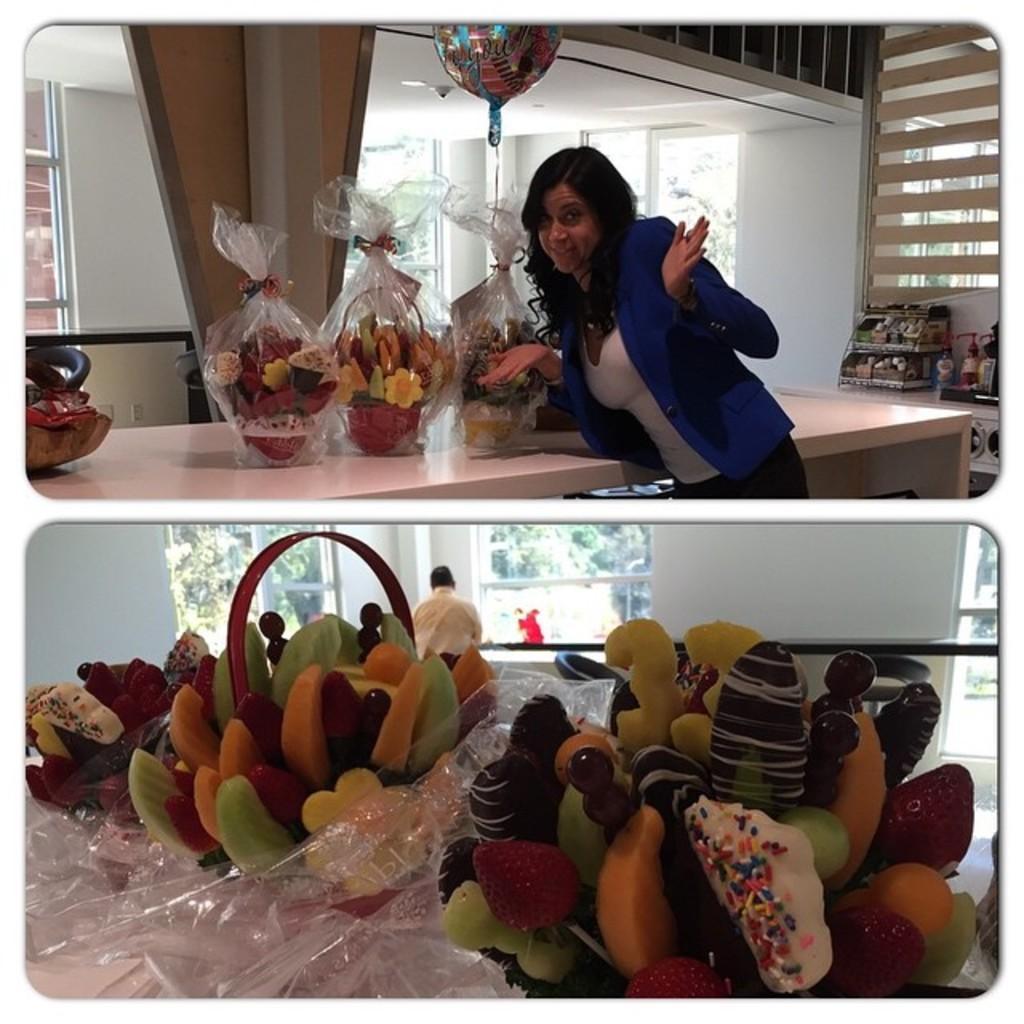In one or two sentences, can you explain what this image depicts? In this picture I can see at the bottom it looks like there are cut fruits on the table, at the top there is a woman, she is wearing a blue color coat and beside her there are baskets on a table. In the background there are glass walls, it looks like a photo collage. 